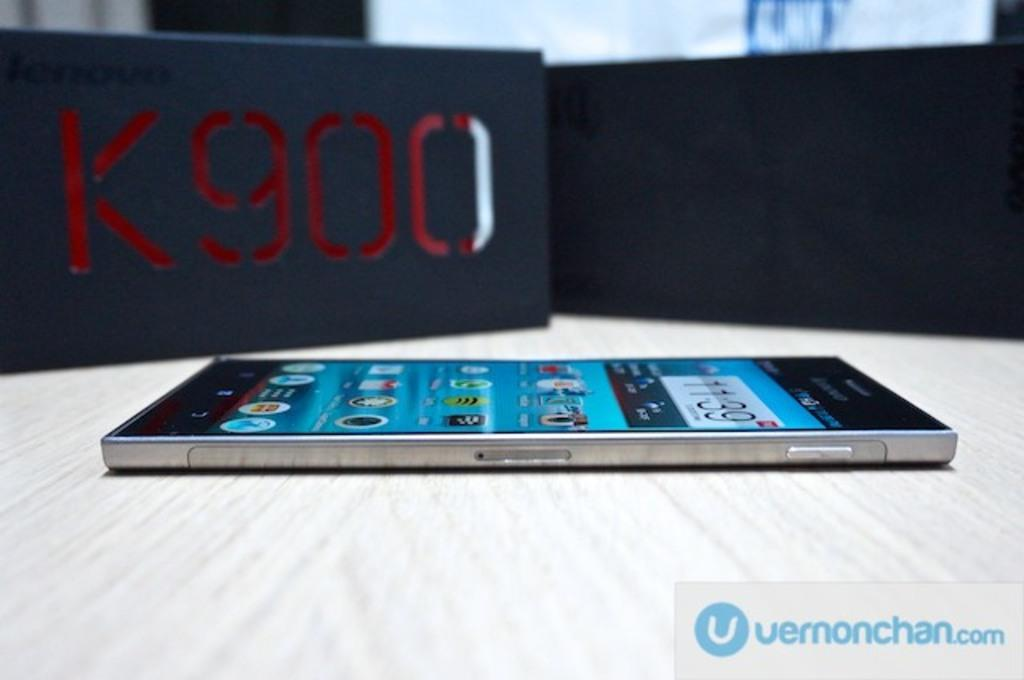<image>
Share a concise interpretation of the image provided. A mobile phone is seen on its back from the side in front of a grey block with K900 written on it in red. 